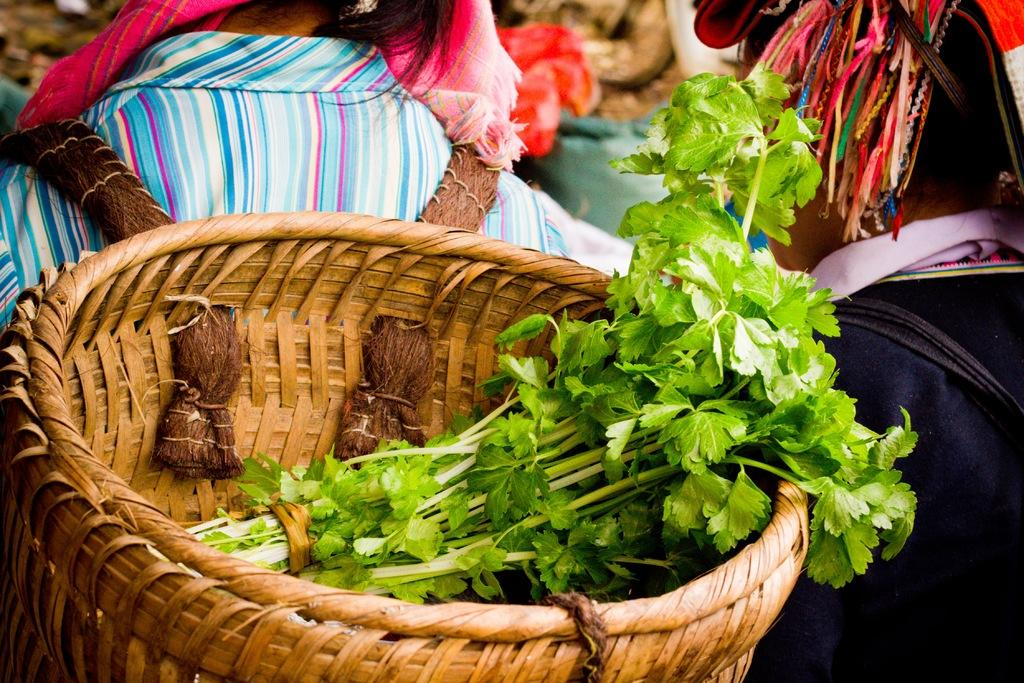What is in the basket that is visible in the image? There are coriander leaves in a basket. Who is wearing the basket in the image? The basket is worn by a person. Can you describe the other person in the image? There is another person on the right side of the image. What book is the person reading in the image? There is no book or reading activity depicted in the image. 